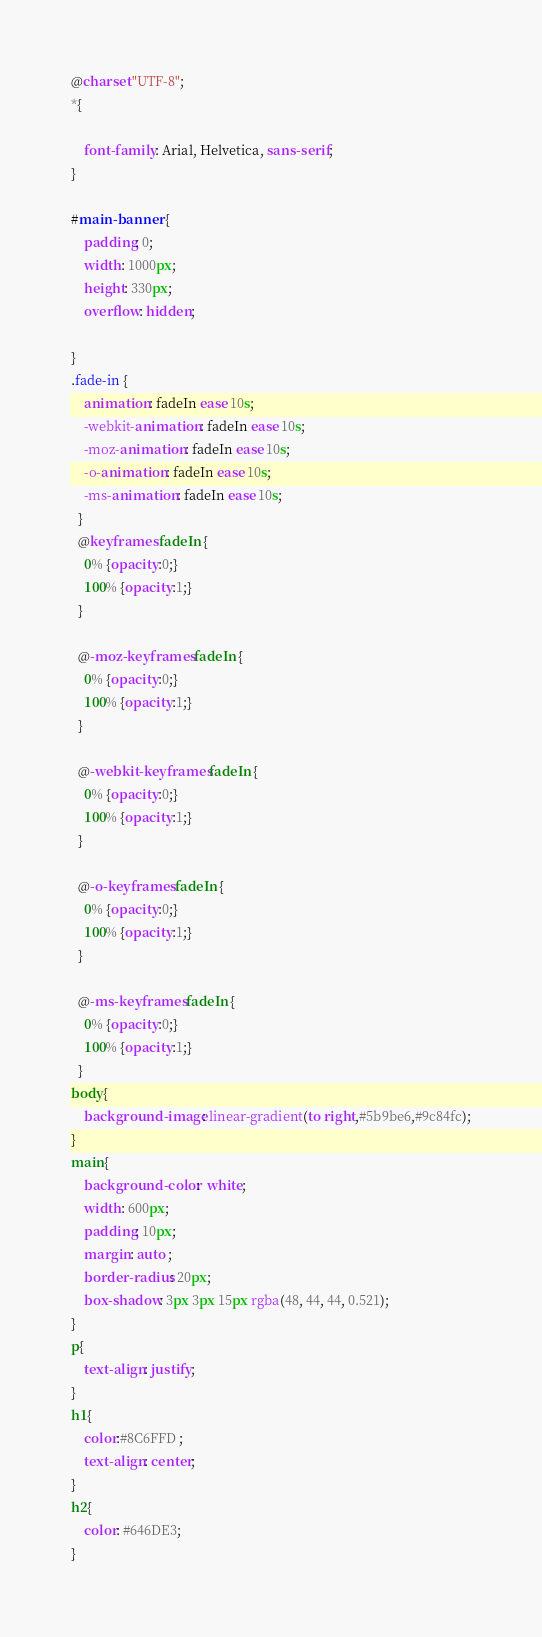Convert code to text. <code><loc_0><loc_0><loc_500><loc_500><_CSS_>@charset "UTF-8";
*{
    
    font-family: Arial, Helvetica, sans-serif;
}

#main-banner {
    padding: 0;
    width: 1000px;
    height: 330px;
    overflow: hidden;
    
}
.fade-in {
    animation: fadeIn ease 10s;
    -webkit-animation: fadeIn ease 10s;
    -moz-animation: fadeIn ease 10s;
    -o-animation: fadeIn ease 10s;
    -ms-animation: fadeIn ease 10s;
  }
  @keyframes fadeIn {
    0% {opacity:0;}
    100% {opacity:1;}
  }
  
  @-moz-keyframes fadeIn {
    0% {opacity:0;}
    100% {opacity:1;}
  }
  
  @-webkit-keyframes fadeIn {
    0% {opacity:0;}
    100% {opacity:1;}
  }
  
  @-o-keyframes fadeIn {
    0% {opacity:0;}
    100% {opacity:1;}
  }
  
  @-ms-keyframes fadeIn {
    0% {opacity:0;}
    100% {opacity:1;}
  }
body{
    background-image: linear-gradient(to right,#5b9be6,#9c84fc);
}
main{
    background-color:  white;
    width: 600px;
    padding: 10px;
    margin: auto ;
    border-radius: 20px;
    box-shadow: 3px 3px 15px rgba(48, 44, 44, 0.521);
}
p{
    text-align: justify;
}
h1{
    color:#8C6FFD ;
    text-align: center;
}
h2{
    color: #646DE3;
}
</code> 